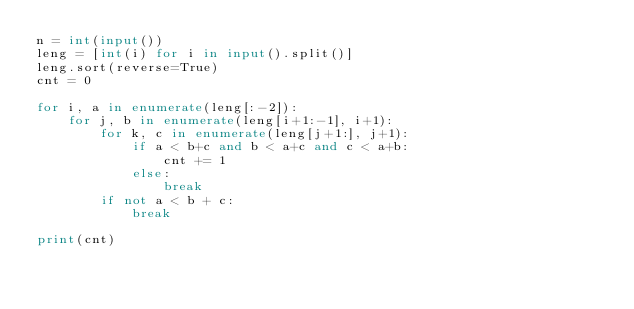Convert code to text. <code><loc_0><loc_0><loc_500><loc_500><_Python_>n = int(input())
leng = [int(i) for i in input().split()]
leng.sort(reverse=True)
cnt = 0

for i, a in enumerate(leng[:-2]):
    for j, b in enumerate(leng[i+1:-1], i+1):
        for k, c in enumerate(leng[j+1:], j+1):
            if a < b+c and b < a+c and c < a+b:
                cnt += 1
            else:
                break
        if not a < b + c:
            break

print(cnt)
</code> 